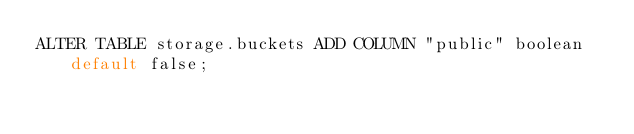<code> <loc_0><loc_0><loc_500><loc_500><_SQL_>ALTER TABLE storage.buckets ADD COLUMN "public" boolean default false;</code> 